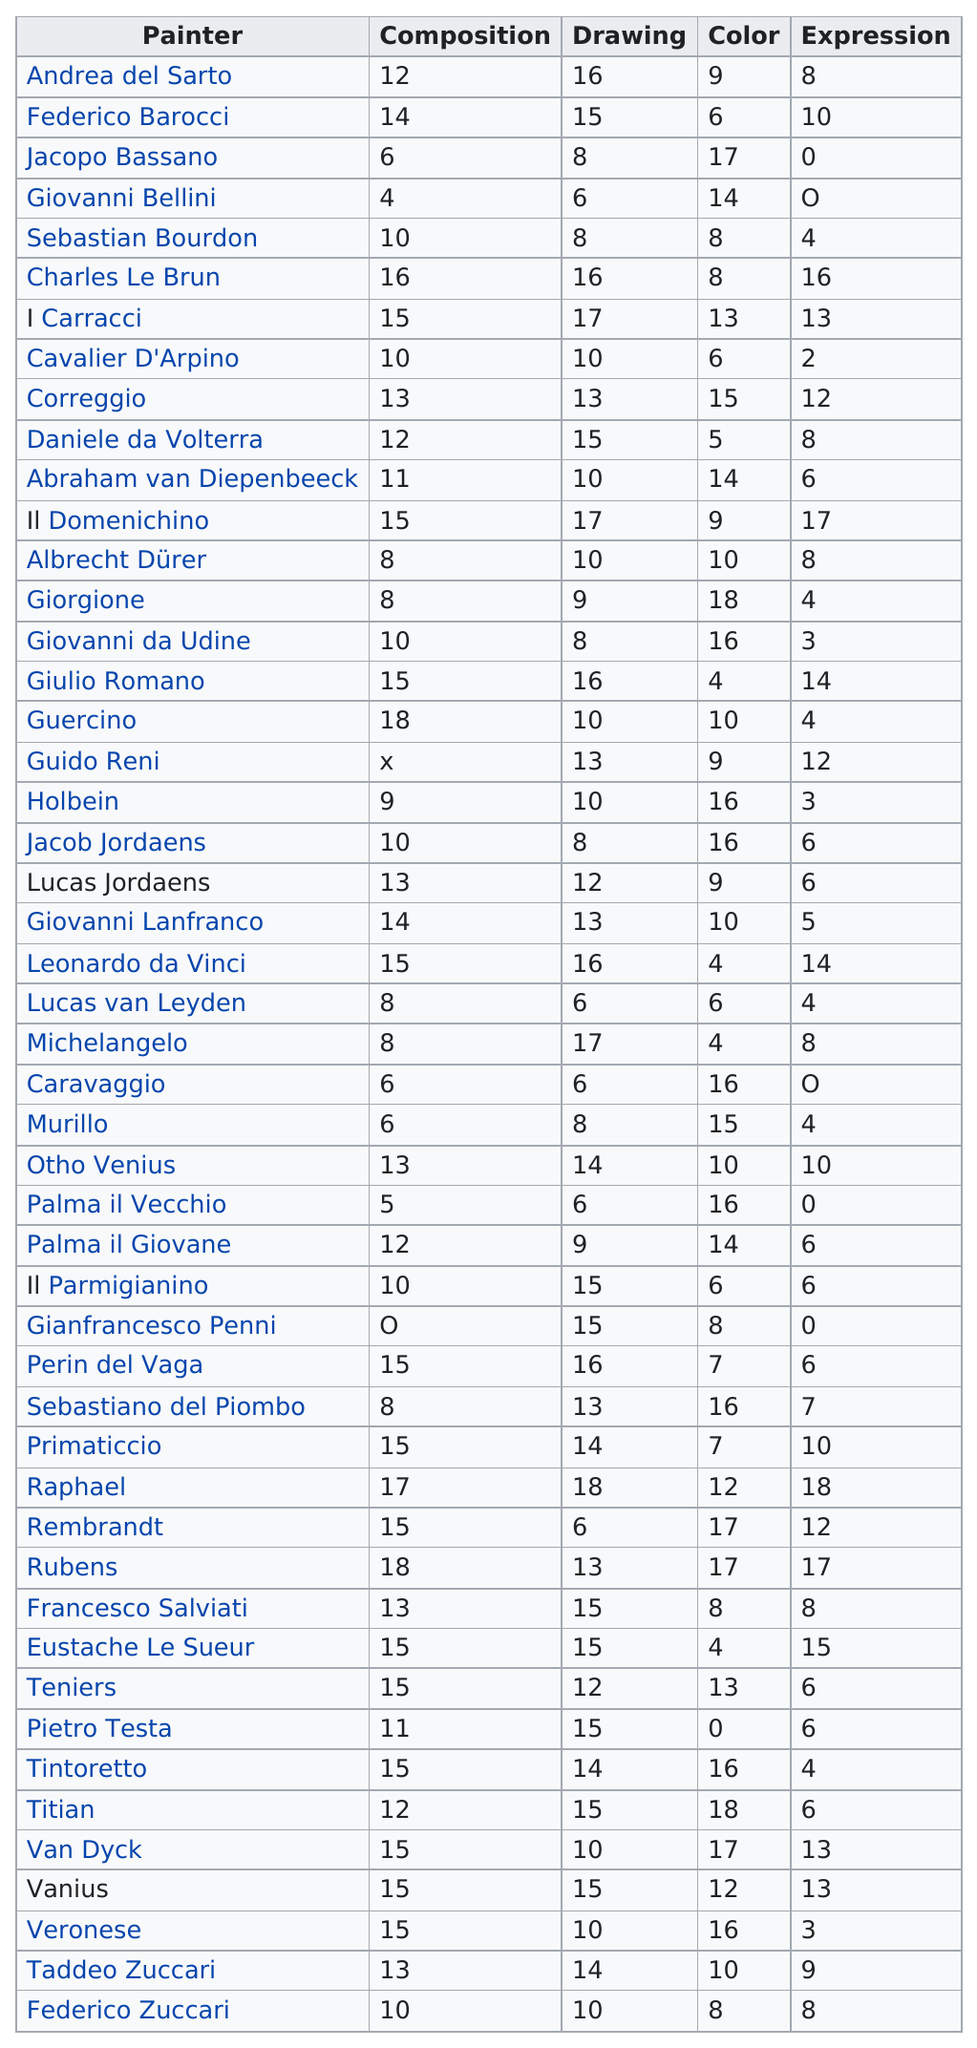Point out several critical features in this image. There were a total of 4 painters who scored 12 in composition. Guercino and Rubens are the artists who have the greatest marks in composition. The artists Charles Le Brun, Guercino, Raphael, and Rubens each scored at least 16 out of 20 in the category of composition. It is known that 5 artists scored 0 for expression. Out of the three painters assessed, a total of 14 painters received a mark for color. 